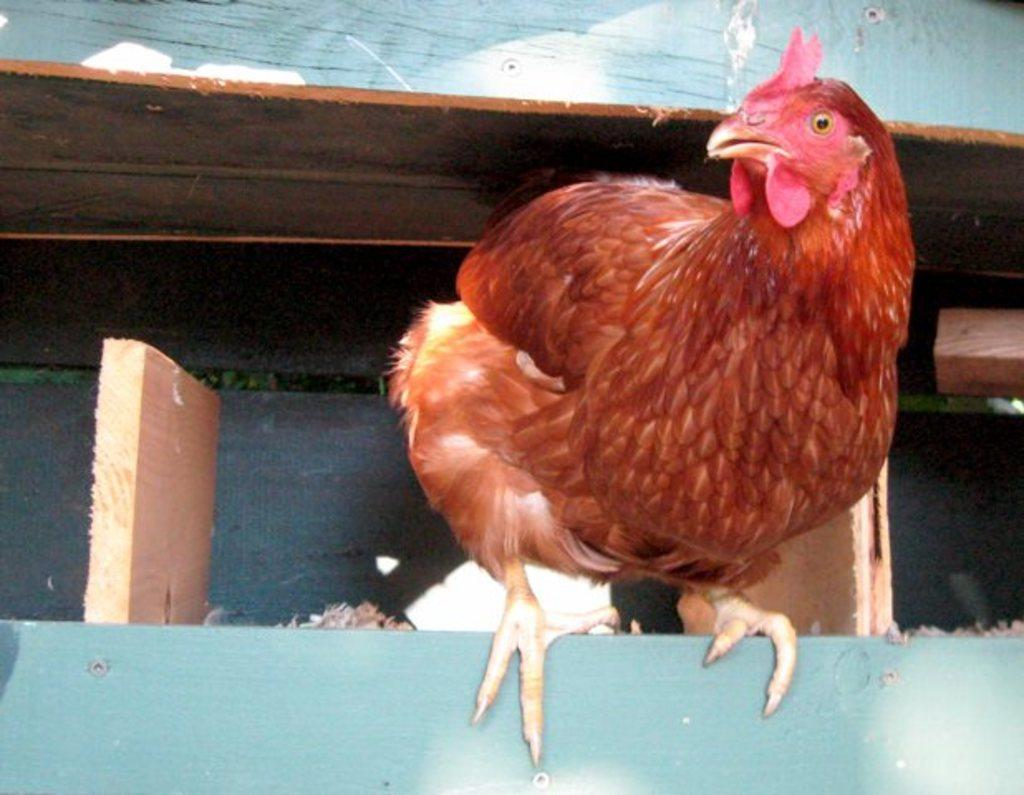What type of animal is in the image? There is a hen in the image. What is the hen standing on? The hen is on a wooden surface. Are there any wooden objects in the image? Yes, there are wooden objects in the image. What can be seen in the background of the image? The background of the image is visible. Can you see the hen's ear in the image? There are no ears visible on the hen in the image, as birds do not have external ears like mammals. 